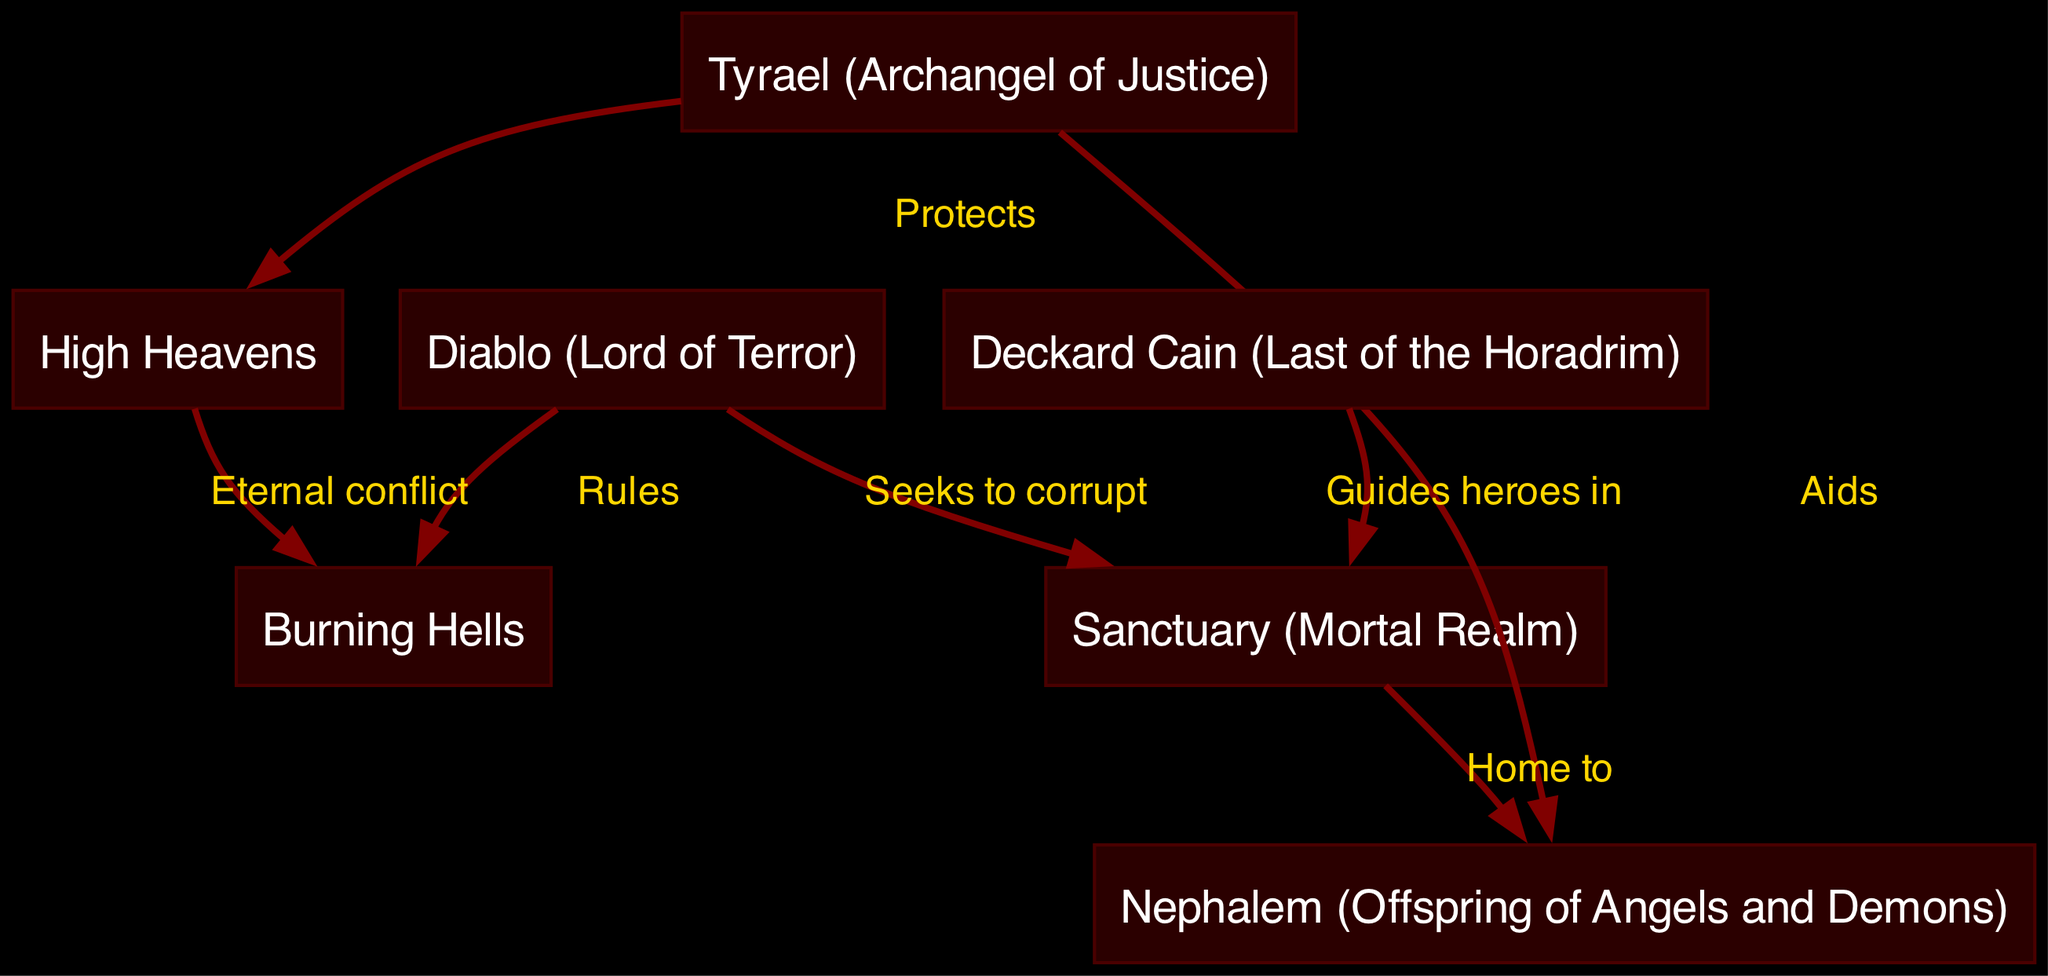What is the role of Tyrael in the diagram? Tyrael is labeled as the "Archangel of Justice" and is shown to protect the "High Heavens" in the diagram. This role signifies his responsibility to defend and uphold justice above all.
Answer: Protects How many nodes are present in the diagram? The diagram includes 7 nodes: Diablo, Tyrael, Deckard Cain, Sanctuary, High Heavens, Burning Hells, and Nephalem. By counting these labeled entities, we arrive at the total.
Answer: 7 What does Diablo seek to do in Sanctuary? The diagram explicitly states that Diablo seeks to corrupt Sanctuary. This denotes his malevolent intention towards the mortal realm, emphasizing his role as the "Lord of Terror."
Answer: Corrupt Which two realms are in eternal conflict according to the diagram? The diagram shows a direct relationship indicating that the "High Heavens" and "Burning Hells" are in eternal conflict. This relationship highlights the ongoing struggle between good and evil within the lore.
Answer: High Heavens and Burning Hells What connection does Deckard Cain have with Sanctuary? The diagram indicates that Deckard Cain guides heroes in Sanctuary. His role as a mentor figures prominently in the narrative of heroes combating evil forces.
Answer: Guides heroes in How does Tyrael support the Nephalem according to the relationships in the diagram? The diagram displays that Tyrael aids the Nephalem, who are the offspring of angels and demons. This support reflects his involvement with those who are caught between the celestial and infernal forces.
Answer: Aids What can be inferred about the Nephalem's origin based on the diagram? The diagram indicates that Nephalem are the offspring of angels and demons, and it portrays Sanctuary as their home. This dual heritage is significant in understanding their unique abilities and role in the conflict.
Answer: Offspring of Angels and Demons Who is described as the last of the Horadrim? In the diagram, Deckard Cain is explicitly labeled as the last of the Horadrim. This title indicates his historical significance and connection to the lore surrounding ancient guardians against evil.
Answer: Deckard Cain 